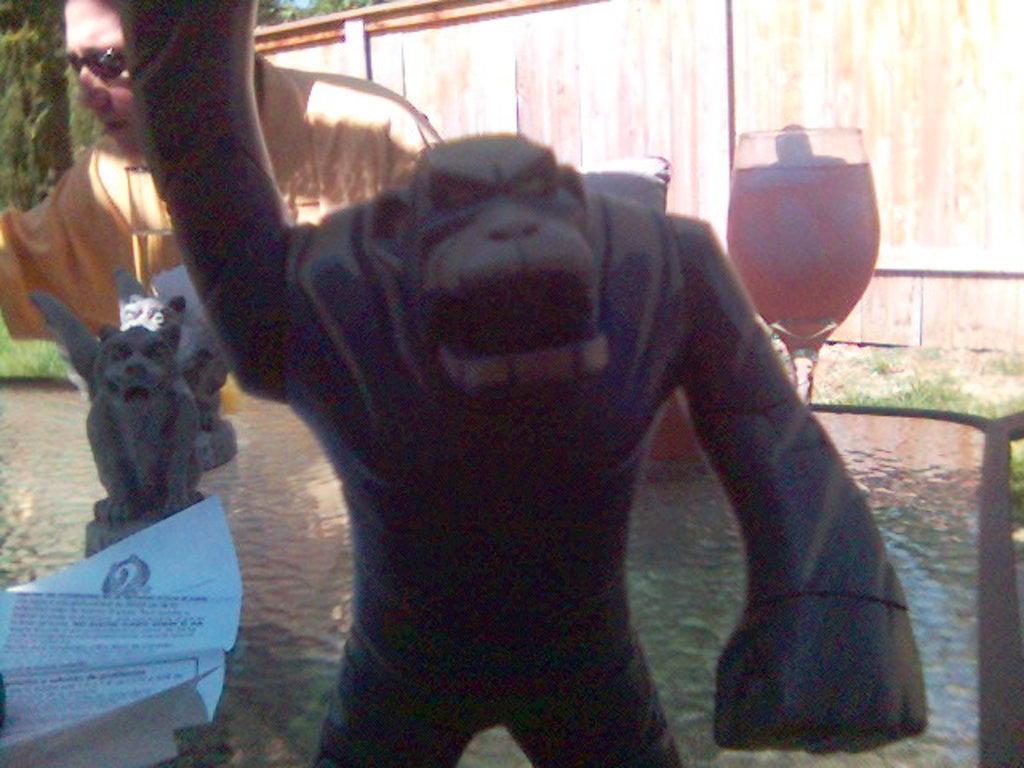How would you summarize this image in a sentence or two? In the image there is a statue of a monkey in the front, behind it there are few statues of other animals on left side and wine glass on right side, there is a person standing on left side, in the background there is a wooden wall with trees behind it. 